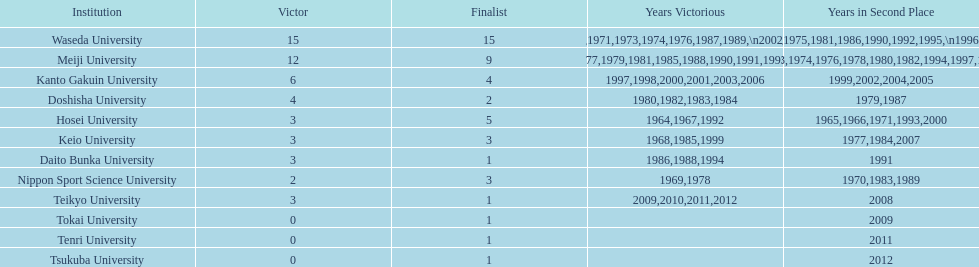Who won the last championship recorded on this table? Teikyo University. 